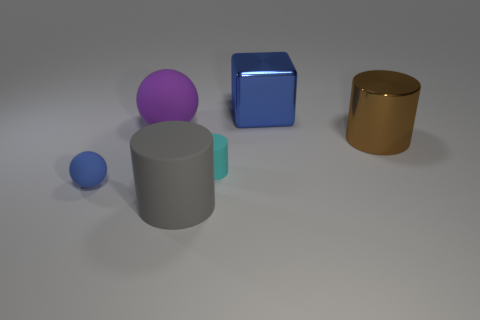Add 2 big blue metal things. How many objects exist? 8 Subtract all blocks. How many objects are left? 5 Add 6 tiny rubber cylinders. How many tiny rubber cylinders exist? 7 Subtract 0 green balls. How many objects are left? 6 Subtract all tiny rubber objects. Subtract all blue metallic blocks. How many objects are left? 3 Add 5 large metal blocks. How many large metal blocks are left? 6 